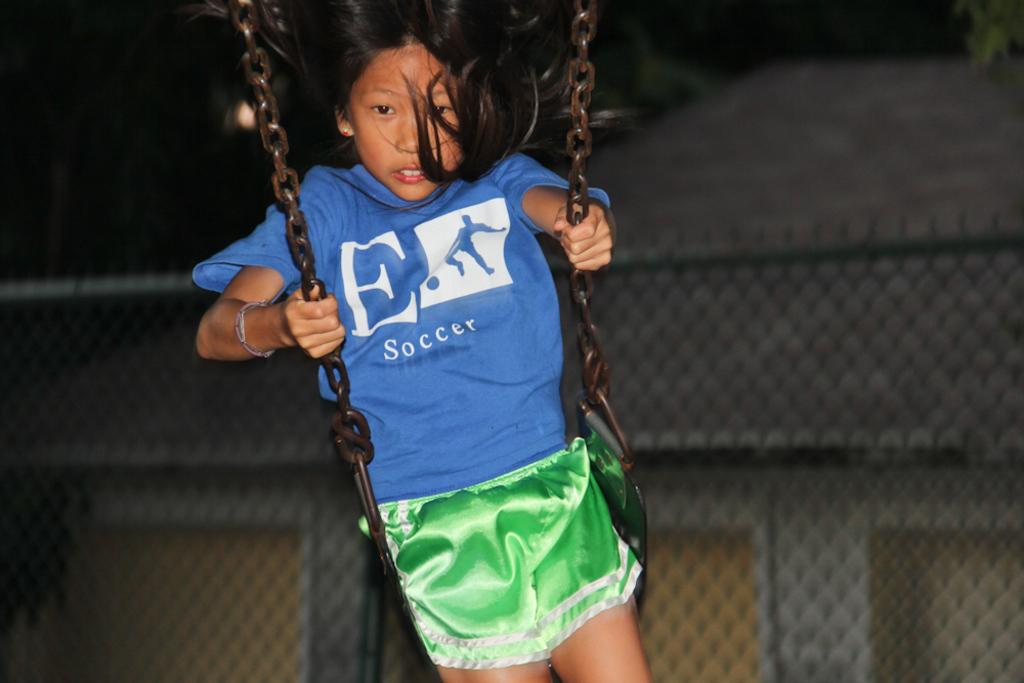What letter is on the girls shirt?
Your response must be concise. E. 